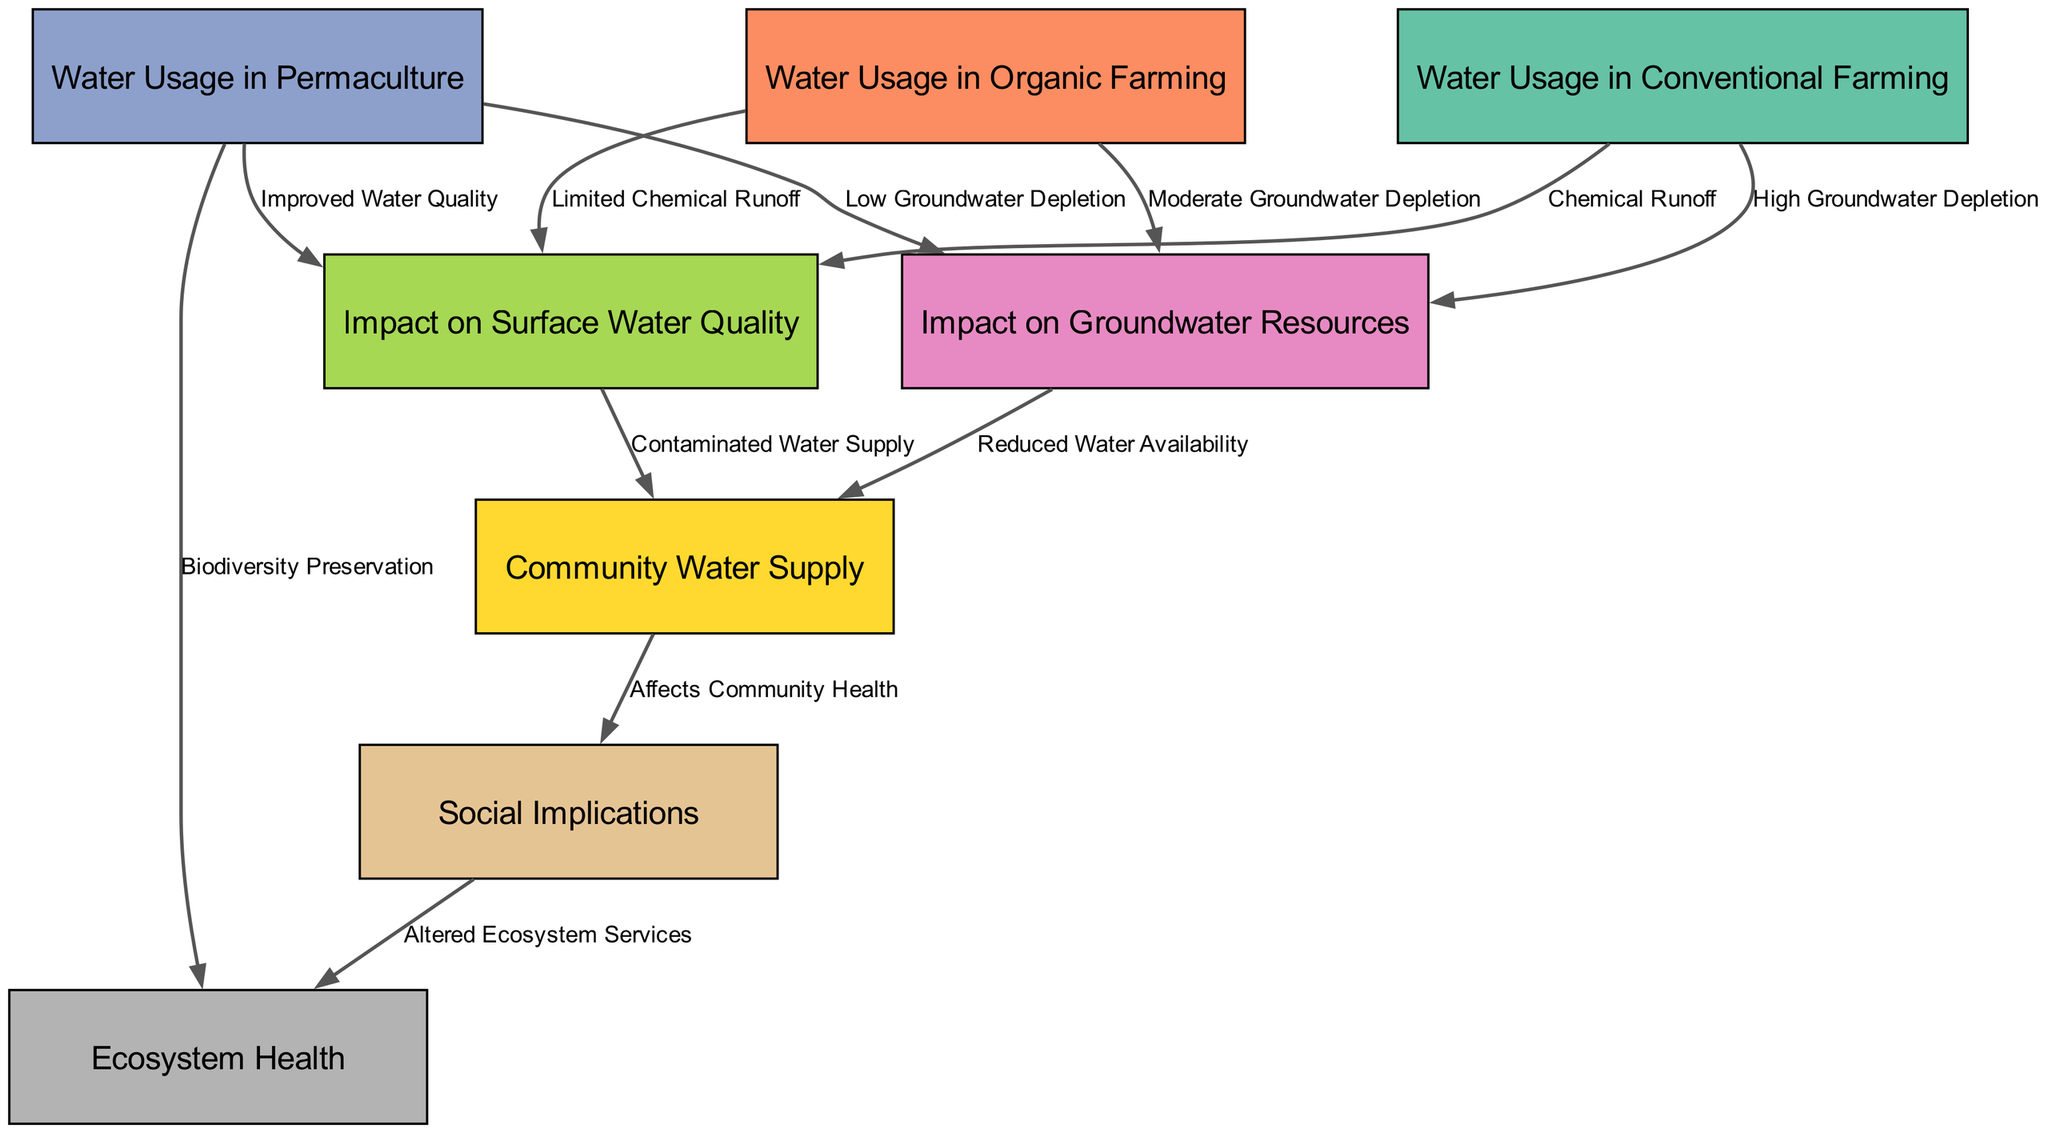What is the water usage in conventional farming? The diagram shows that the water usage in conventional farming is linked to "High Groundwater Depletion" and "Chemical Runoff." By examining the node "Water Usage in Conventional Farming," we can determine that it directly represents a high level of water consumption.
Answer: High Groundwater Depletion What is the impact of organic farming on groundwater resources? From the diagram, we can see that organic farming has a relationship labeled "Moderate Groundwater Depletion" leading to the node "Impact on Groundwater Resources." This shows that while organic farming uses water, it does so at a lesser impact compared to conventional farming.
Answer: Moderate Groundwater Depletion How many nodes are there in the diagram? To find the number of nodes, we can simply count them in the data provided. The nodes listed include: Water Usage in Conventional Farming, Water Usage in Organic Farming, Water Usage in Permaculture, Impact on Groundwater Resources, Impact on Surface Water Quality, Community Water Supply, Social Implications, and Ecosystem Health. This gives us a total of eight nodes.
Answer: 8 Which farming technique has the lowest groundwater depletion? Looking at the connections for each farming technique, we see that "Permaculture" is associated with "Low Groundwater Depletion." This indicates it has the least impact regarding groundwater usage among the techniques displayed.
Answer: Low Groundwater Depletion What is the outcome of contaminated water supply on community health? The diagram illustrates a connection where "Contaminated Water Supply" affects "Community Water Supply," which then leads to "Affects Community Health." Therefore, the implications of contaminated water supply lead to health issues for the community.
Answer: Affects Community Health What label is associated with the edge from "Water Usage in Permaculture" to "Ecosystem Health"? The connection from "Water Usage in Permaculture" to "Ecosystem Health" is described as "Biodiversity Preservation." This means that the usage of water in permaculture positively influences ecosystem health through preserving biodiversity.
Answer: Biodiversity Preservation What is the relationship between surface water quality and community water supply? The diagram shows that "Impact on Surface Water Quality" is linked to "Community Water Supply" through "Contaminated Water Supply." This indicates that poor surface water quality leads to contamination of the community's water resources.
Answer: Contaminated Water Supply 